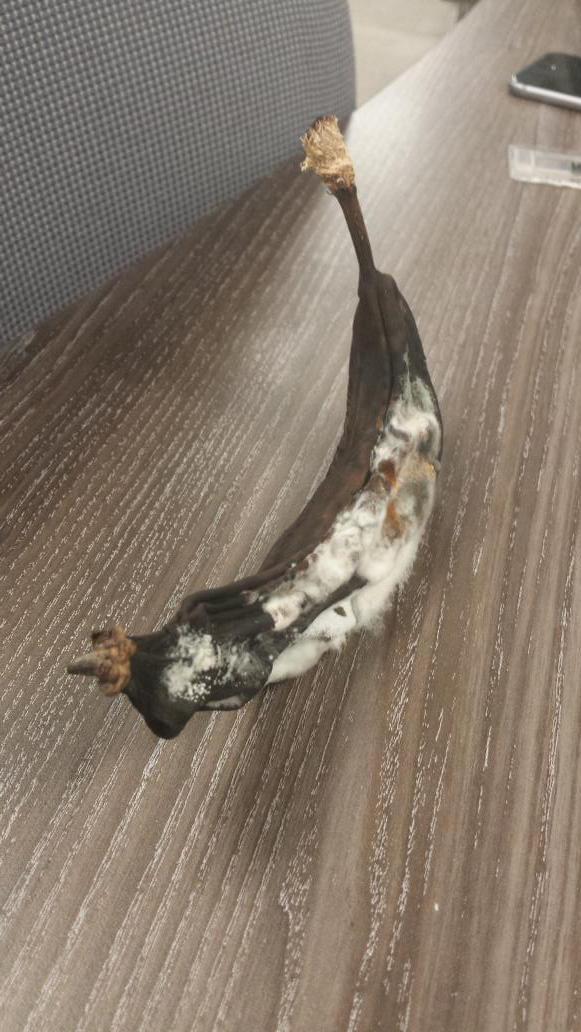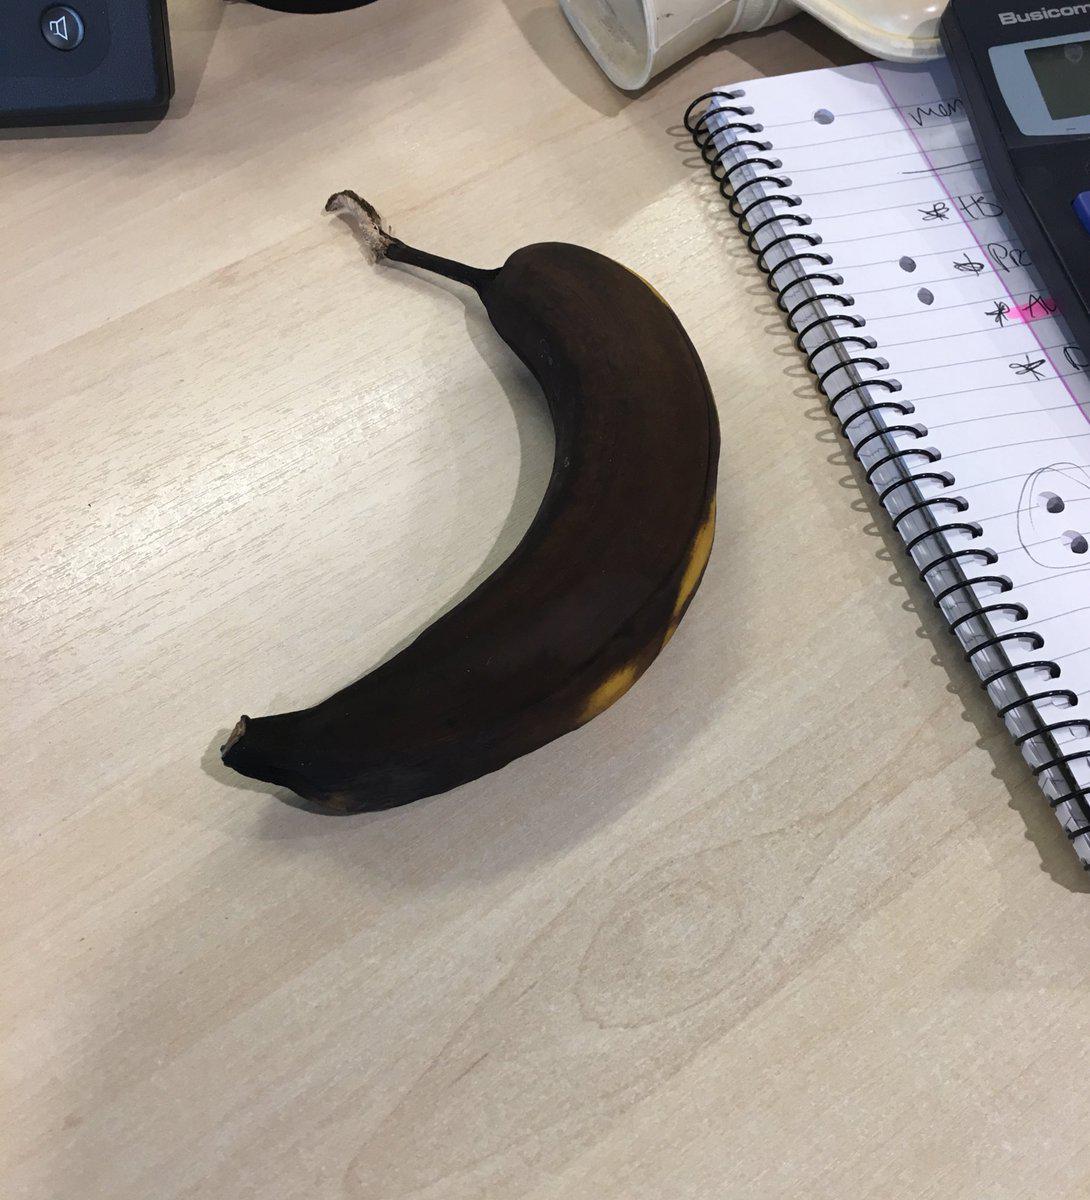The first image is the image on the left, the second image is the image on the right. Analyze the images presented: Is the assertion "Two bananas are sitting on a desk, and at least one of them is sitting beside a piece of paper." valid? Answer yes or no. Yes. The first image is the image on the left, the second image is the image on the right. For the images shown, is this caption "A banana is on a reddish-brown woodgrain surface in the right image, and a banana is by a cup-like container in the left image." true? Answer yes or no. No. 